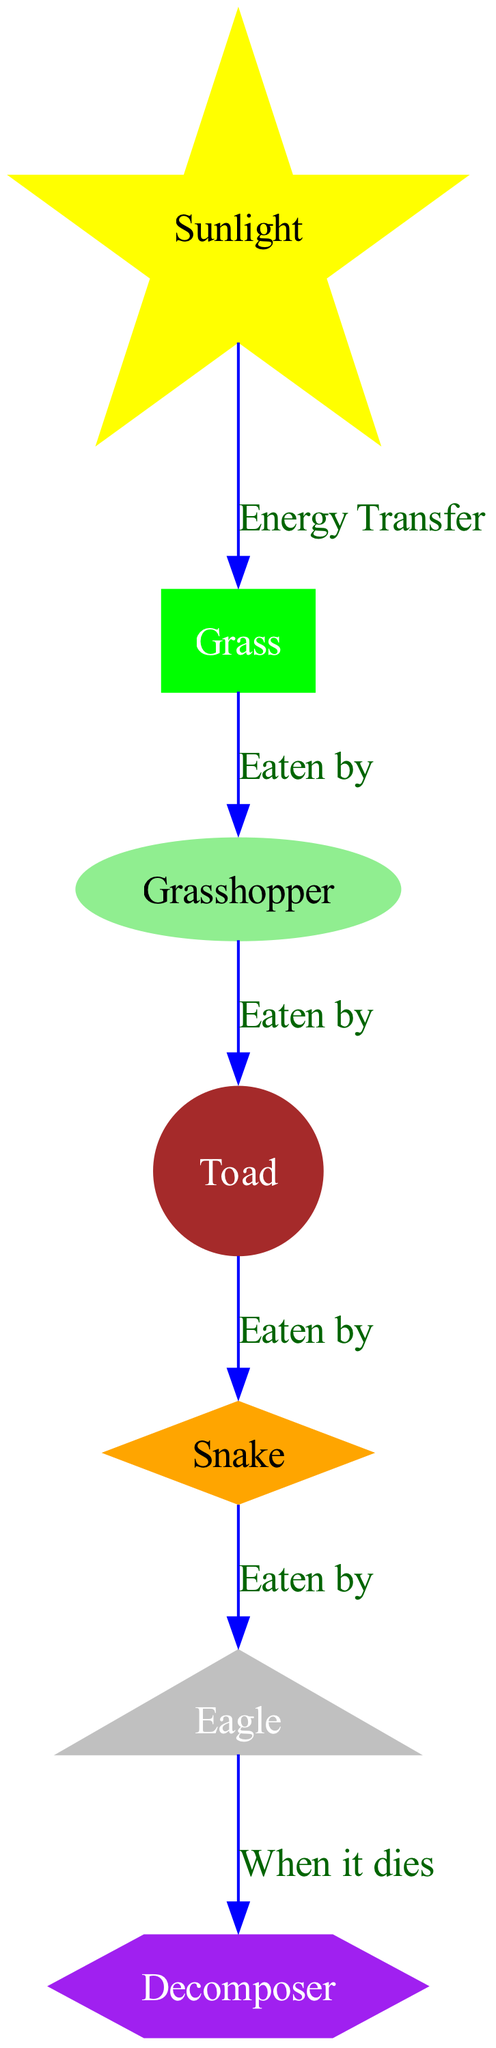What is the first source of energy in the food chain? The first node in the diagram represents the sun, which provides sunlight to the ecosystem, making it the primary source of energy.
Answer: Sunlight How many nodes are there in the diagram? By counting all the unique nodes presented in the diagram, there are a total of seven (sunlight, grass, grasshopper, toad, snake, eagle, decomposer).
Answer: Seven Which organism is eaten by the eagle? The diagram indicates a direct line from the snake to the eagle, meaning the eagle consumes the snake as its prey.
Answer: Snake What is the role of the decomposer in this food chain? The decomposer receives energy when an organism, in this case, the eagle, dies. This shows the role of the decomposer in recycling nutrients back into the ecosystem.
Answer: Recycling nutrients Which organism is directly eaten by the grasshopper? According to the diagram, grass is directly consumed by the grasshopper, indicating a primary consumer relationship.
Answer: Grass How does energy flow from sunlight to decomposers in the food chain? Energy flows from sunlight to grass (first trophic level), then to the grasshopper (second trophic level), followed by the toad (third), snake (fourth), eagle (fifth), and finally to the decomposer when the eagle dies. This sequence illustrates the transfer of energy through various trophic levels down to the decomposer.
Answer: Through multiple trophic levels What is the relationship between the toad and the snake in the food chain? The diagram displays a direct relationship where the toad is eaten by the snake, representing a predator-prey interaction.
Answer: Eaten by 